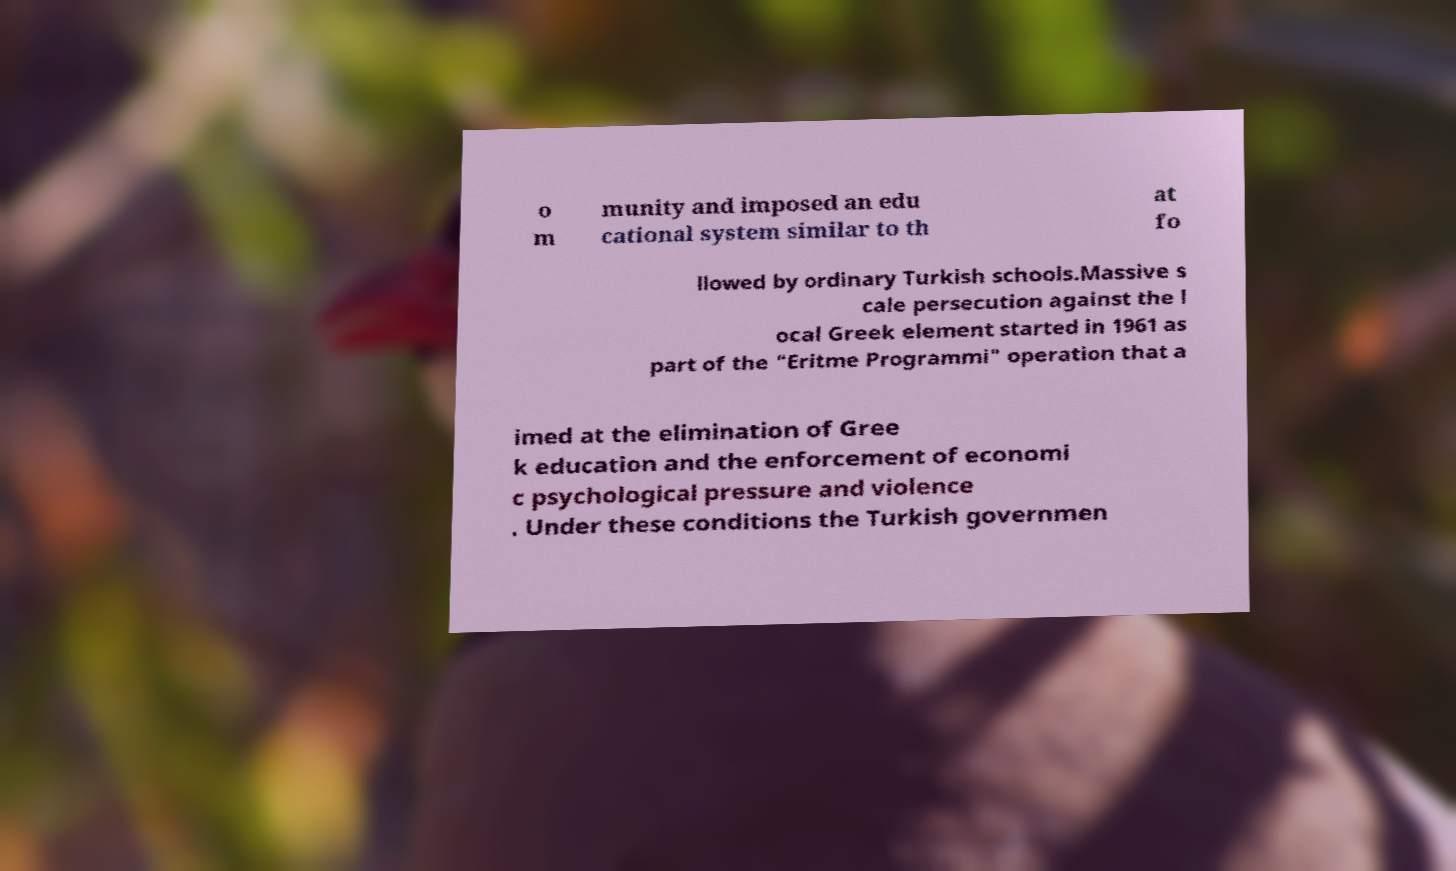Could you extract and type out the text from this image? o m munity and imposed an edu cational system similar to th at fo llowed by ordinary Turkish schools.Massive s cale persecution against the l ocal Greek element started in 1961 as part of the "Eritme Programmi" operation that a imed at the elimination of Gree k education and the enforcement of economi c psychological pressure and violence . Under these conditions the Turkish governmen 